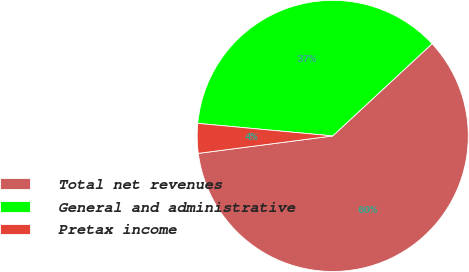<chart> <loc_0><loc_0><loc_500><loc_500><pie_chart><fcel>Total net revenues<fcel>General and administrative<fcel>Pretax income<nl><fcel>59.85%<fcel>36.62%<fcel>3.53%<nl></chart> 